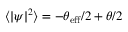Convert formula to latex. <formula><loc_0><loc_0><loc_500><loc_500>\langle | \psi | ^ { 2 } \rangle = - \theta _ { e f f } / 2 + \theta / 2</formula> 